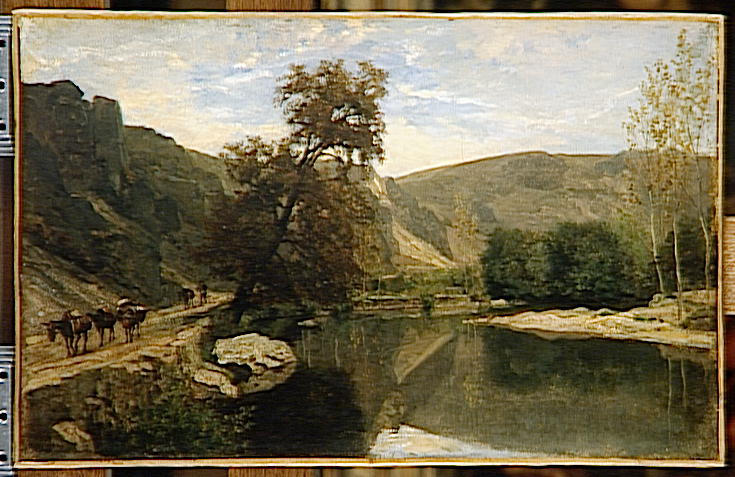Can you elaborate on the elements of the picture provided? This artwork is a classic example of an impressionist landscape painting, where loose, dynamic brushstrokes capture the beauty of a serene countryside scene. The painting utilizes a naturalistic color palette dominated by greens, browns, and blues reflecting the earthy environment. We see a placid river curving through a lush valley, contributing to a reflective surface that mirrors the scenic sky and surrounding foliage. In the foreground, a group of four-legged animals, likely cows, enhances the pastoral feel by crossing the shallow stream, subtly integrated into the natural landscape. The composition is anchored by rugged cliffs and a variety of trees, which add depth and texture to the scene. The sky is rendered with soft blue hues and gentle clouds, emphasizing a sense of calmness. The artist's mastery in layering and perspective invites viewers into this tranquil scene, offering a glimpse into a harmonious ecosystem where every element coexists peacefully. The painting not only portrays a beautiful landscape but also evokes a feeling of tranquility and a connection to nature. 